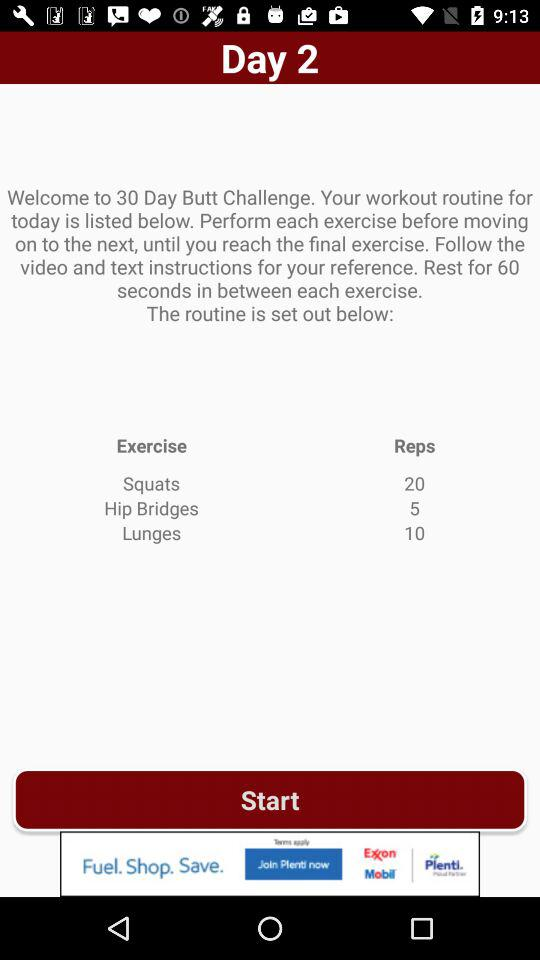How many exercises are there in the workout routine?
Answer the question using a single word or phrase. 3 